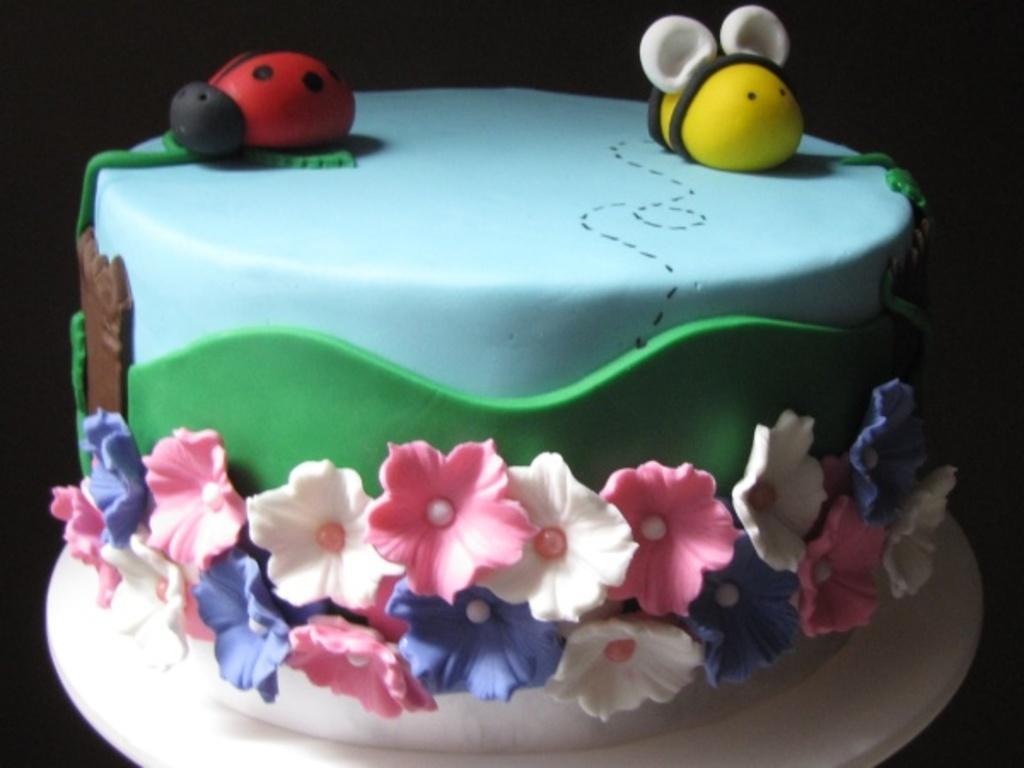Could you give a brief overview of what you see in this image? In this image I can see the cake in red, black, yellow, white, brown, blue, green, pink and purple color. Background is in black color. 